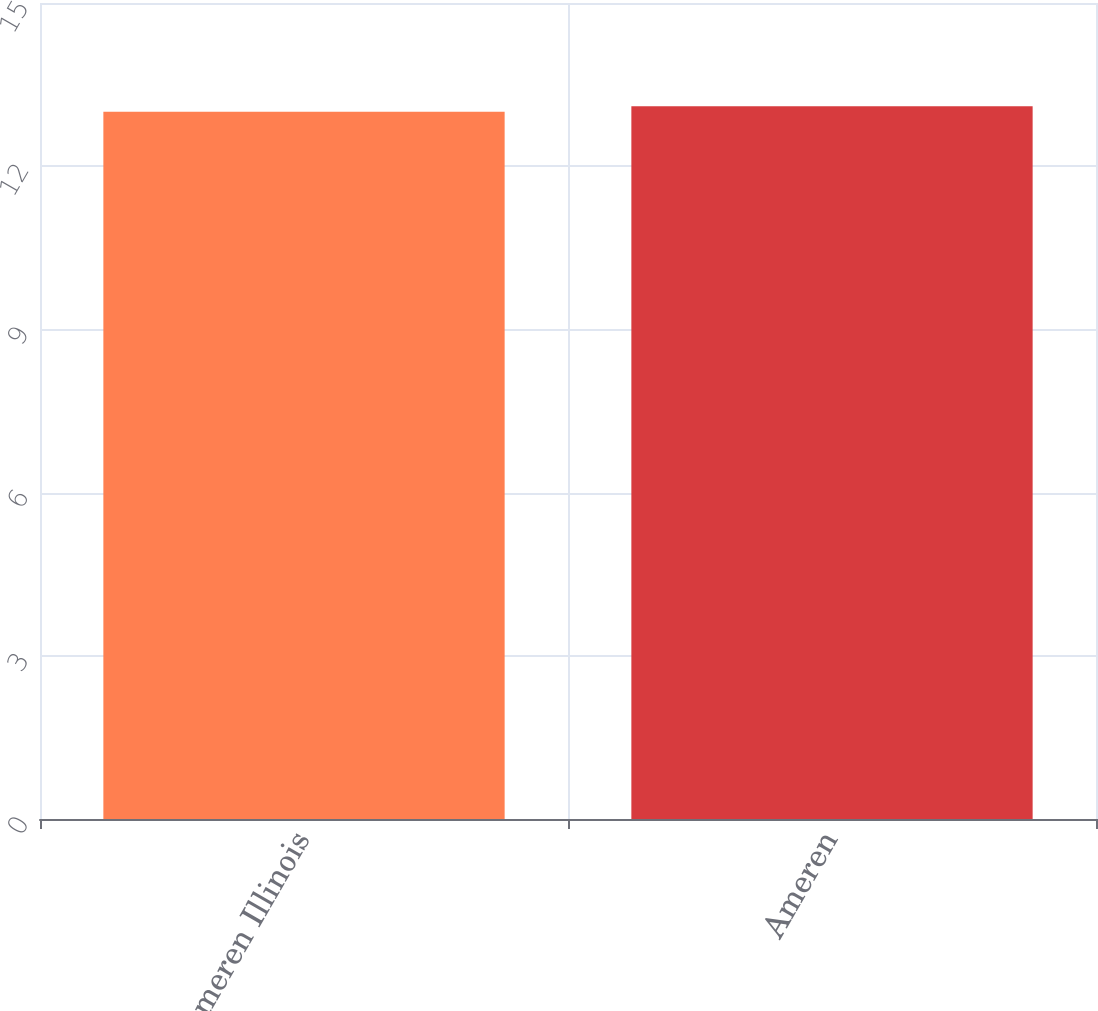Convert chart to OTSL. <chart><loc_0><loc_0><loc_500><loc_500><bar_chart><fcel>Ameren Illinois<fcel>Ameren<nl><fcel>13<fcel>13.1<nl></chart> 